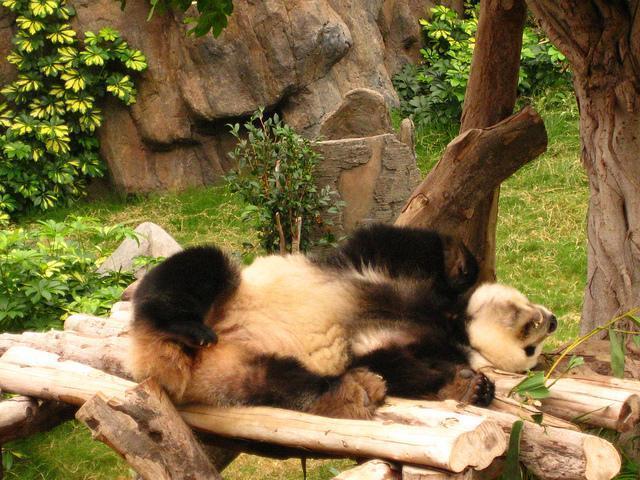How many people are wearing bracelets?
Give a very brief answer. 0. 